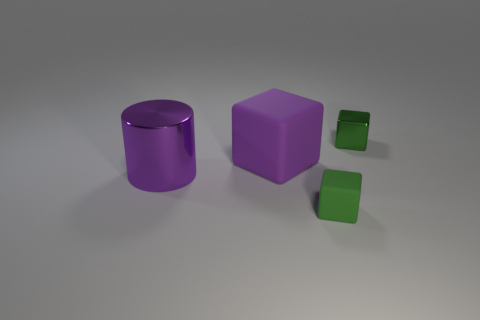There is a cylinder that is the same color as the large cube; what is its material?
Offer a terse response. Metal. What number of blocks are the same color as the tiny shiny object?
Offer a very short reply. 1. Are there an equal number of purple cylinders that are to the right of the purple cube and big gray rubber objects?
Give a very brief answer. Yes. What color is the cylinder?
Ensure brevity in your answer.  Purple. The other block that is the same material as the purple cube is what size?
Ensure brevity in your answer.  Small. There is a small cube that is the same material as the big purple block; what color is it?
Your response must be concise. Green. Is there a purple metal cylinder that has the same size as the purple rubber object?
Your answer should be very brief. Yes. What is the material of the other tiny green thing that is the same shape as the green rubber object?
Provide a succinct answer. Metal. There is another thing that is the same size as the green metallic object; what is its shape?
Provide a succinct answer. Cube. Is there a tiny gray thing of the same shape as the big matte thing?
Keep it short and to the point. No. 